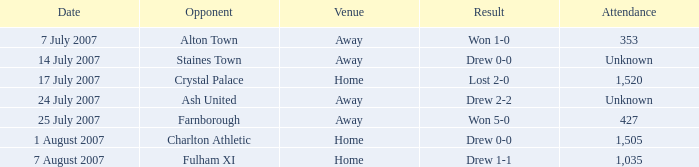Name the venue for staines town Away. 